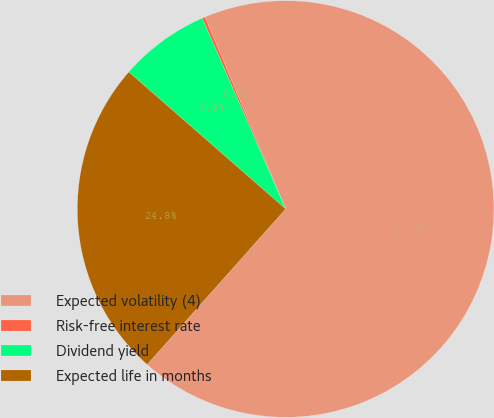Convert chart to OTSL. <chart><loc_0><loc_0><loc_500><loc_500><pie_chart><fcel>Expected volatility (4)<fcel>Risk-free interest rate<fcel>Dividend yield<fcel>Expected life in months<nl><fcel>67.91%<fcel>0.23%<fcel>7.01%<fcel>24.85%<nl></chart> 